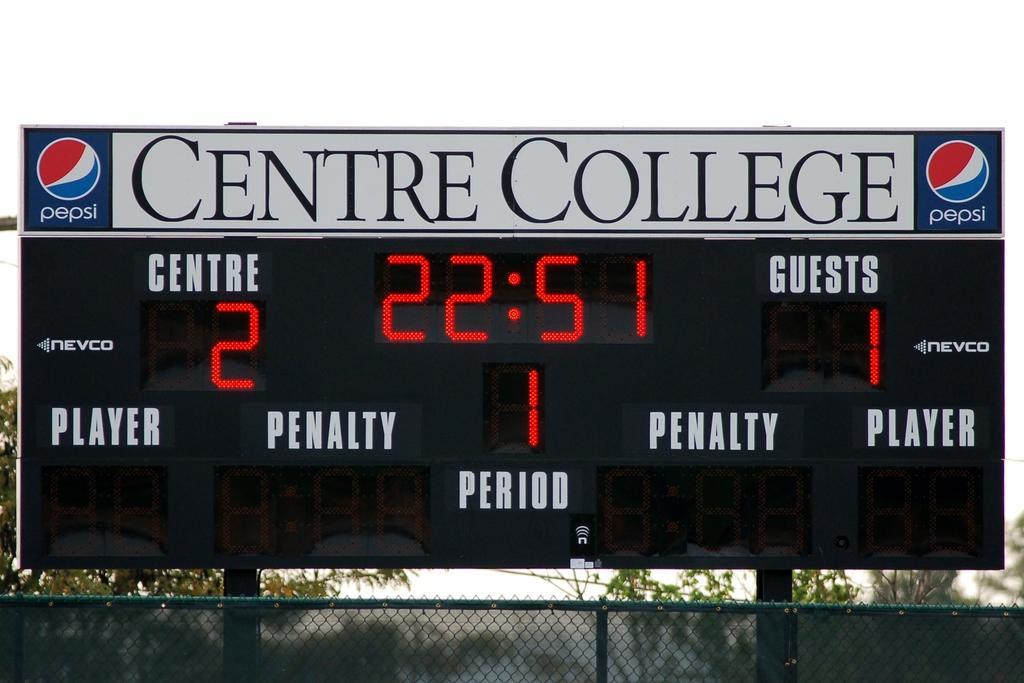Can you describe this image briefly? In this image we can see a display board with name on its top, fence, trees and sky in the background. 